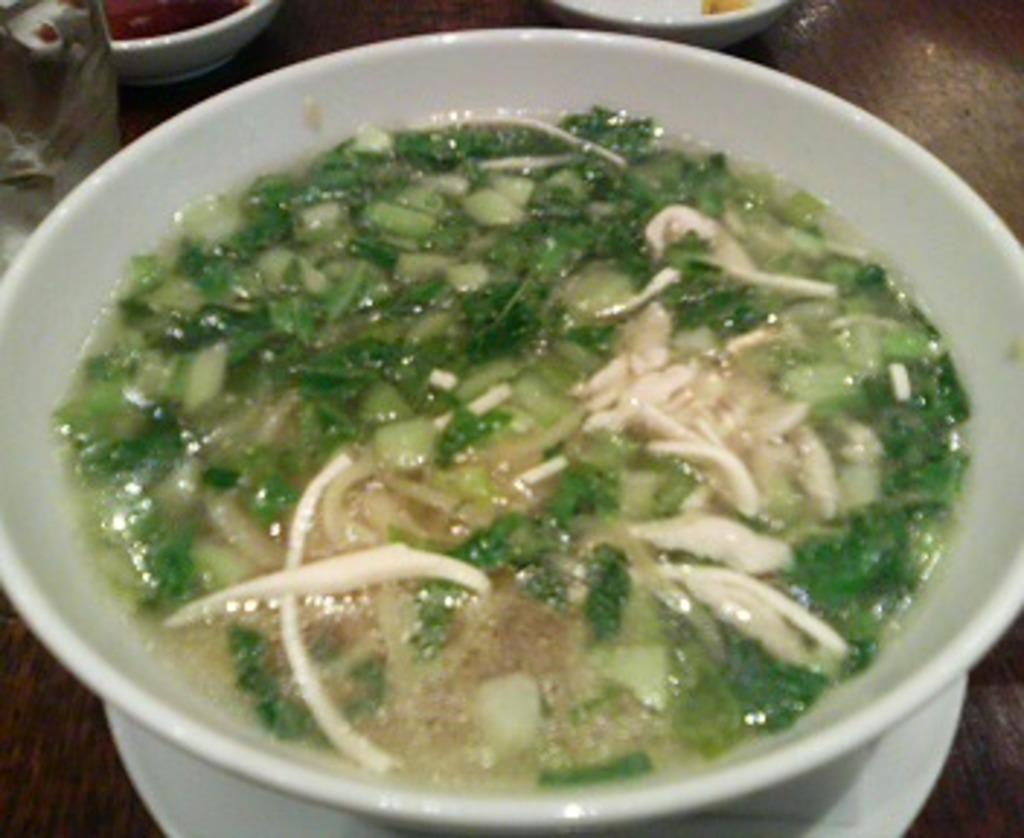What type of table is in the image? There is a wooden table in the image. What items are on the table? There are bowls and a plate on the table. What is the glass object on the table? There is a glass object on the table, but its specific purpose is not clear from the facts provided. What is on the plate? There is a bowl with food on the plate. What year is depicted in the image? The facts provided do not mention any specific year or time period, so it is not possible to determine the year from the image. 